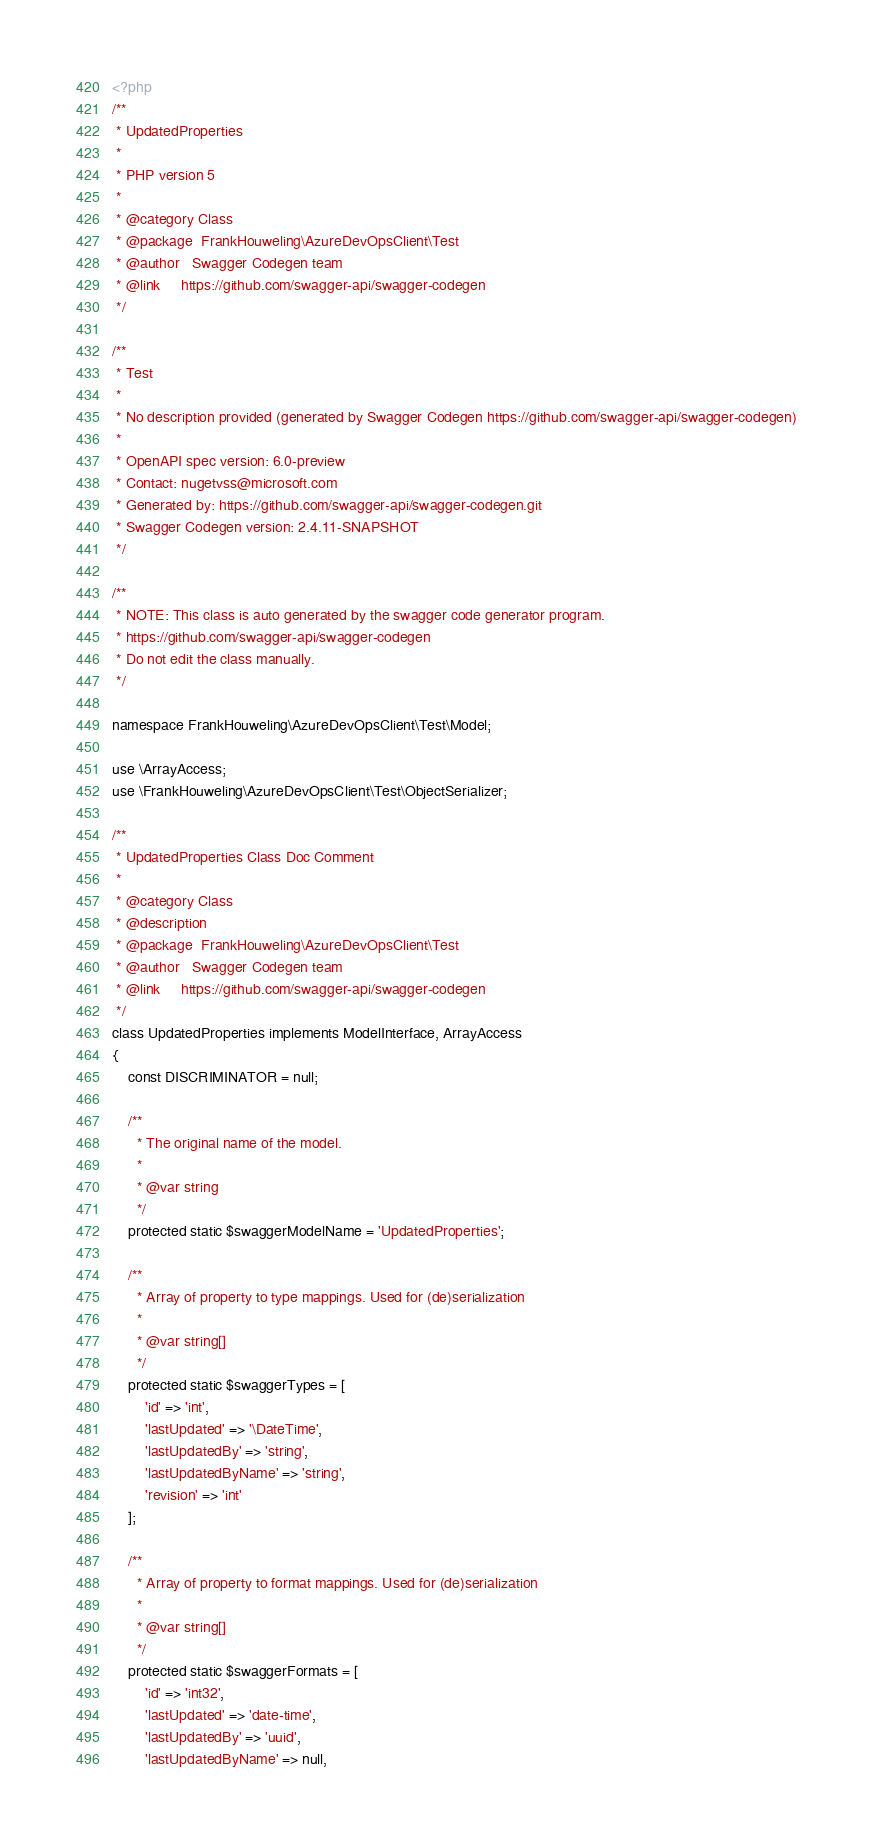<code> <loc_0><loc_0><loc_500><loc_500><_PHP_><?php
/**
 * UpdatedProperties
 *
 * PHP version 5
 *
 * @category Class
 * @package  FrankHouweling\AzureDevOpsClient\Test
 * @author   Swagger Codegen team
 * @link     https://github.com/swagger-api/swagger-codegen
 */

/**
 * Test
 *
 * No description provided (generated by Swagger Codegen https://github.com/swagger-api/swagger-codegen)
 *
 * OpenAPI spec version: 6.0-preview
 * Contact: nugetvss@microsoft.com
 * Generated by: https://github.com/swagger-api/swagger-codegen.git
 * Swagger Codegen version: 2.4.11-SNAPSHOT
 */

/**
 * NOTE: This class is auto generated by the swagger code generator program.
 * https://github.com/swagger-api/swagger-codegen
 * Do not edit the class manually.
 */

namespace FrankHouweling\AzureDevOpsClient\Test\Model;

use \ArrayAccess;
use \FrankHouweling\AzureDevOpsClient\Test\ObjectSerializer;

/**
 * UpdatedProperties Class Doc Comment
 *
 * @category Class
 * @description 
 * @package  FrankHouweling\AzureDevOpsClient\Test
 * @author   Swagger Codegen team
 * @link     https://github.com/swagger-api/swagger-codegen
 */
class UpdatedProperties implements ModelInterface, ArrayAccess
{
    const DISCRIMINATOR = null;

    /**
      * The original name of the model.
      *
      * @var string
      */
    protected static $swaggerModelName = 'UpdatedProperties';

    /**
      * Array of property to type mappings. Used for (de)serialization
      *
      * @var string[]
      */
    protected static $swaggerTypes = [
        'id' => 'int',
        'lastUpdated' => '\DateTime',
        'lastUpdatedBy' => 'string',
        'lastUpdatedByName' => 'string',
        'revision' => 'int'
    ];

    /**
      * Array of property to format mappings. Used for (de)serialization
      *
      * @var string[]
      */
    protected static $swaggerFormats = [
        'id' => 'int32',
        'lastUpdated' => 'date-time',
        'lastUpdatedBy' => 'uuid',
        'lastUpdatedByName' => null,</code> 